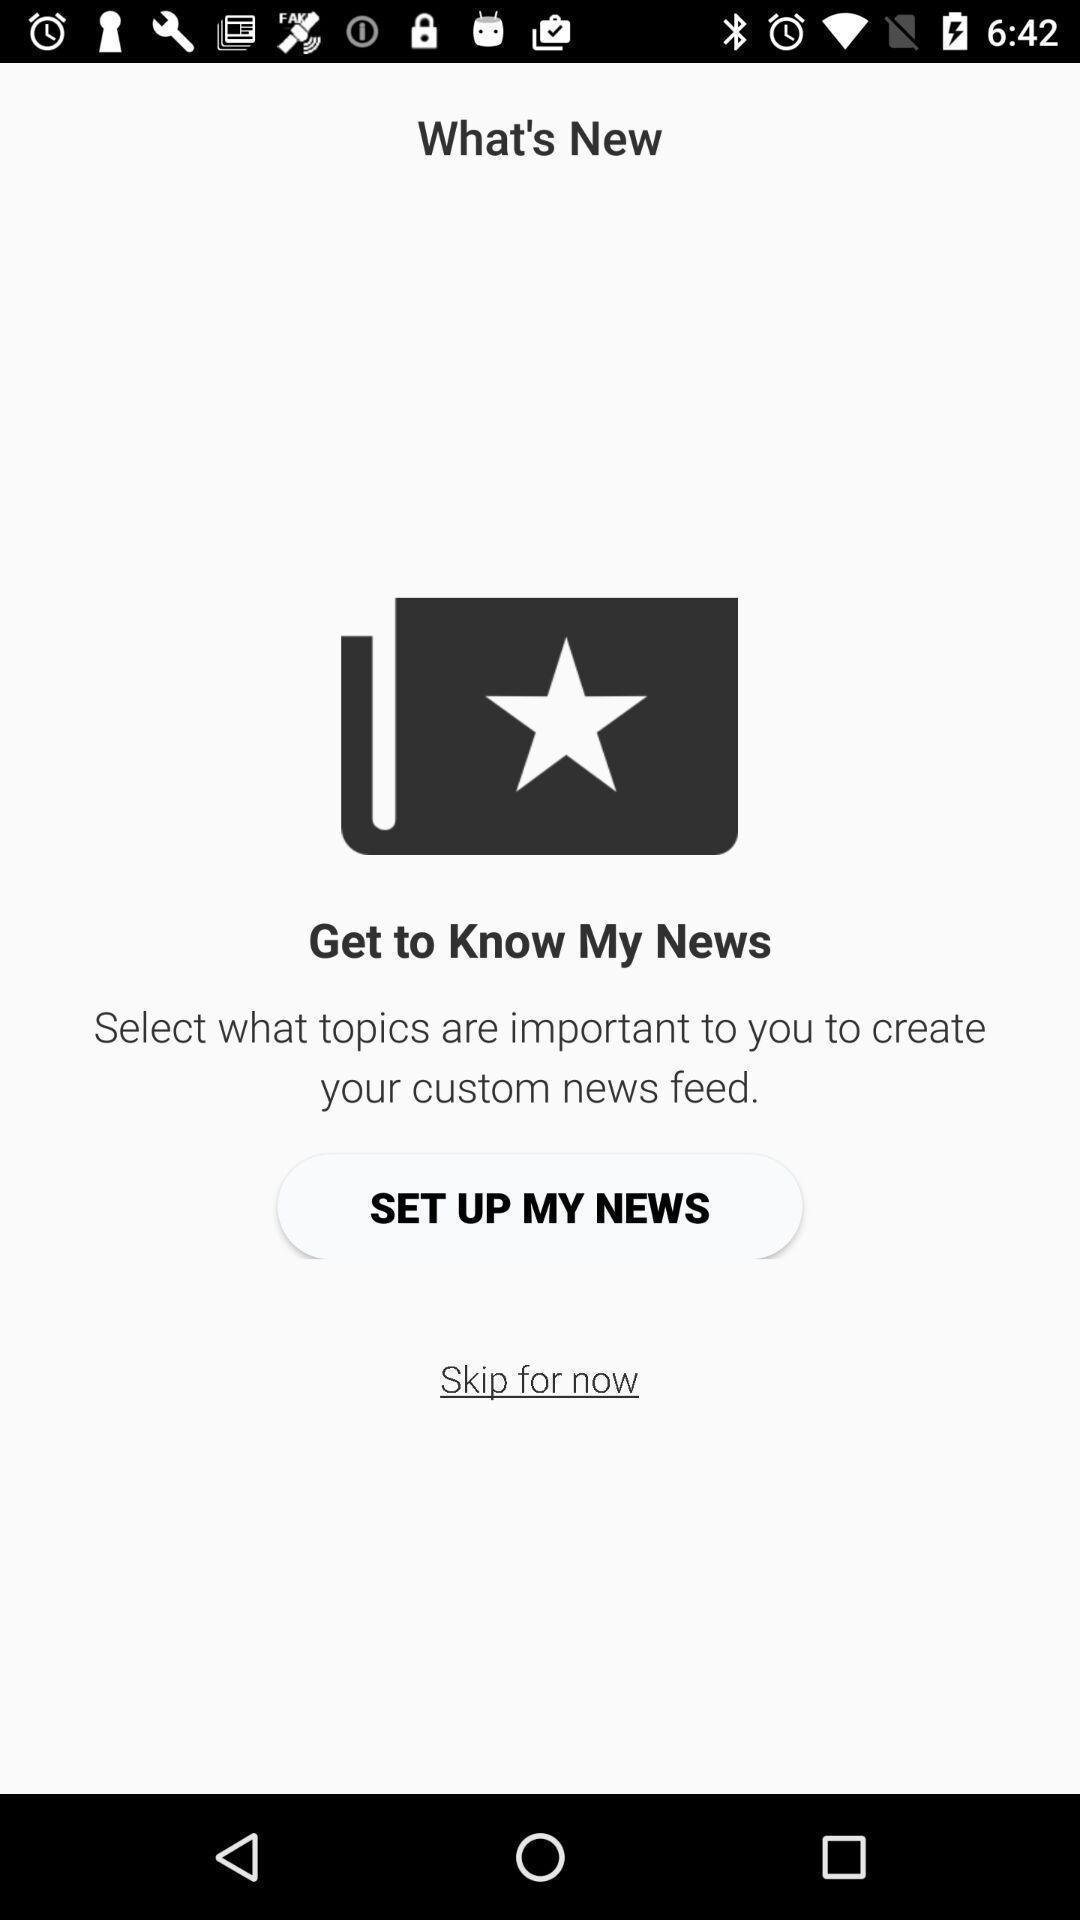Summarize the information in this screenshot. Screen displaying welcome page of a news app. 